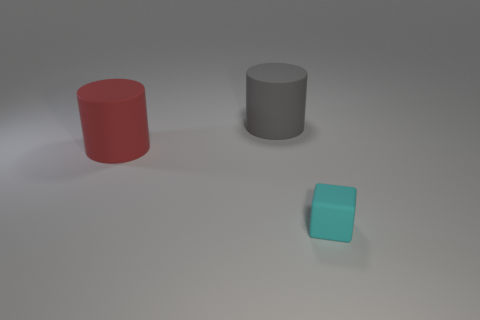Add 2 big matte cylinders. How many objects exist? 5 Subtract all cylinders. How many objects are left? 1 Add 2 tiny things. How many tiny things are left? 3 Add 3 large red cylinders. How many large red cylinders exist? 4 Subtract 0 blue cylinders. How many objects are left? 3 Subtract all large gray matte cylinders. Subtract all cyan matte blocks. How many objects are left? 1 